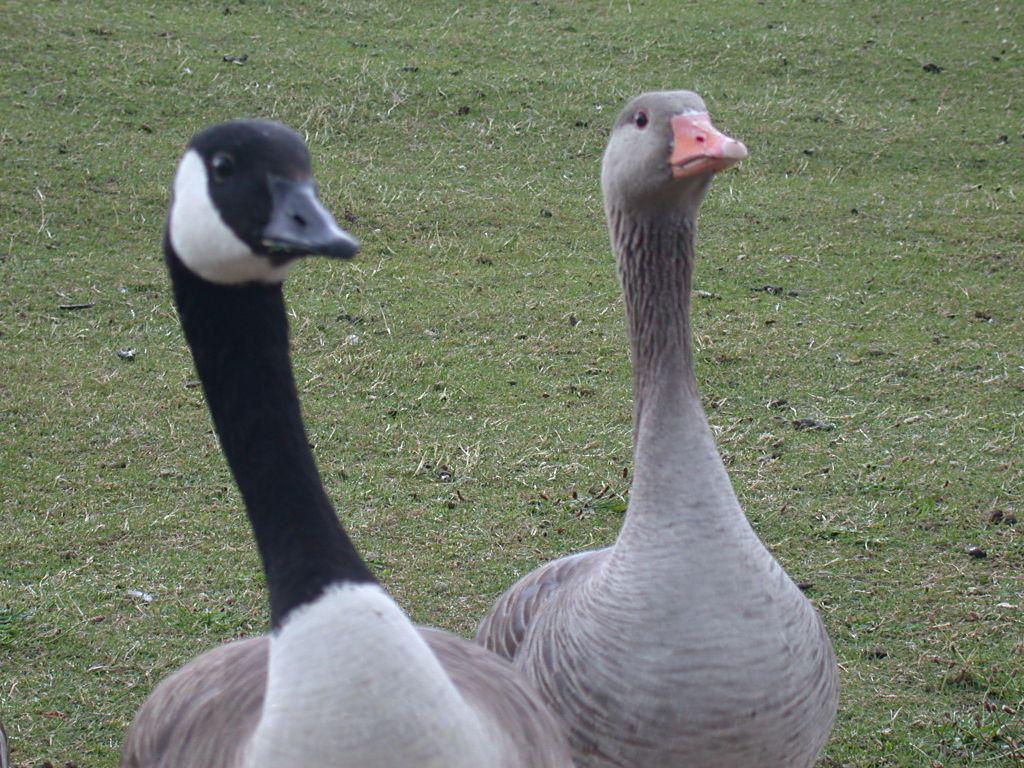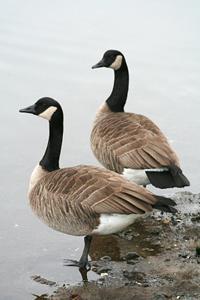The first image is the image on the left, the second image is the image on the right. Considering the images on both sides, is "There are two birds in the right image both facing towards the left." valid? Answer yes or no. Yes. The first image is the image on the left, the second image is the image on the right. For the images shown, is this caption "Two black-necked geese with backs to the camera are standing in water." true? Answer yes or no. Yes. 